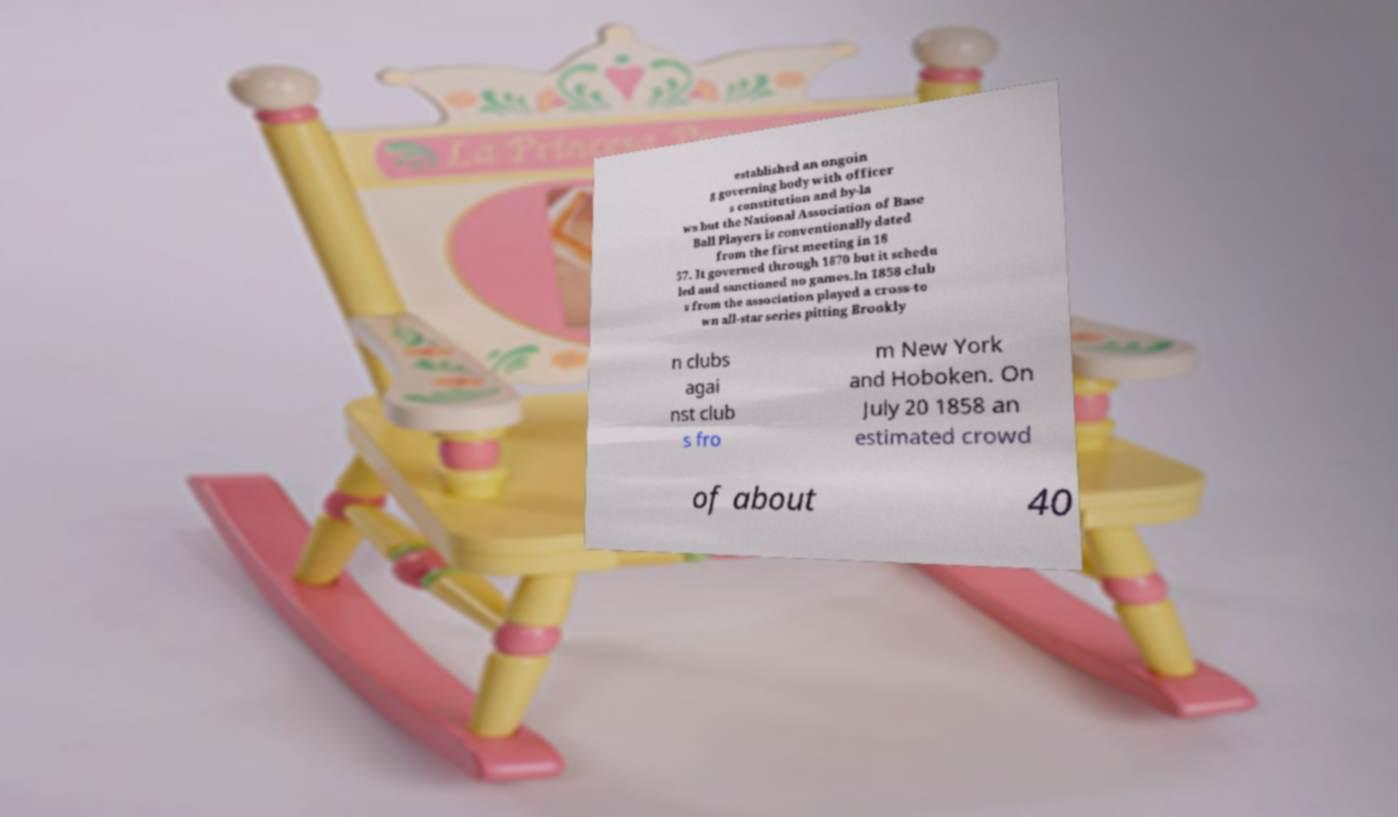Please identify and transcribe the text found in this image. established an ongoin g governing body with officer s constitution and by-la ws but the National Association of Base Ball Players is conventionally dated from the first meeting in 18 57. It governed through 1870 but it schedu led and sanctioned no games.In 1858 club s from the association played a cross-to wn all-star series pitting Brookly n clubs agai nst club s fro m New York and Hoboken. On July 20 1858 an estimated crowd of about 40 